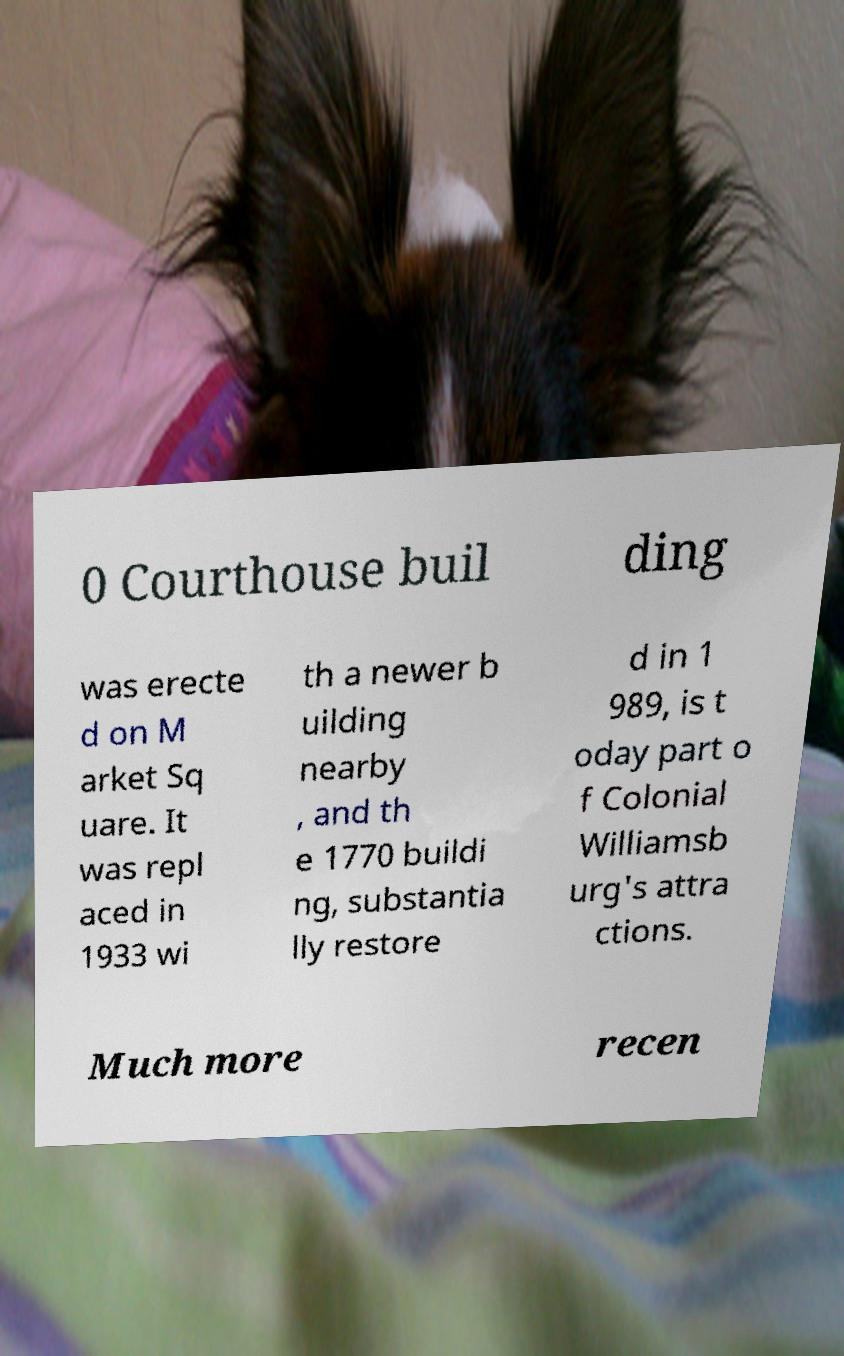What messages or text are displayed in this image? I need them in a readable, typed format. 0 Courthouse buil ding was erecte d on M arket Sq uare. It was repl aced in 1933 wi th a newer b uilding nearby , and th e 1770 buildi ng, substantia lly restore d in 1 989, is t oday part o f Colonial Williamsb urg's attra ctions. Much more recen 